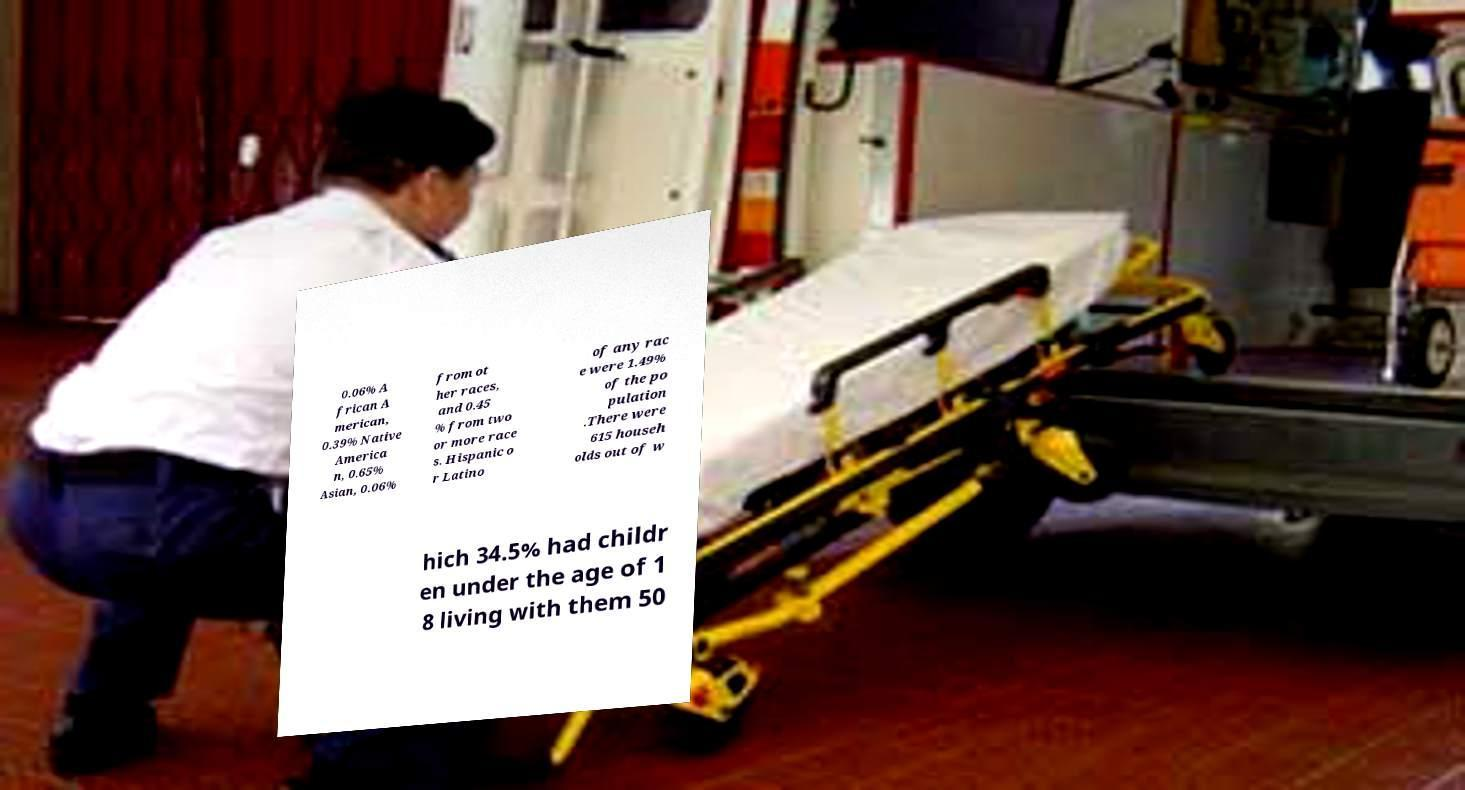Please identify and transcribe the text found in this image. 0.06% A frican A merican, 0.39% Native America n, 0.65% Asian, 0.06% from ot her races, and 0.45 % from two or more race s. Hispanic o r Latino of any rac e were 1.49% of the po pulation .There were 615 househ olds out of w hich 34.5% had childr en under the age of 1 8 living with them 50 